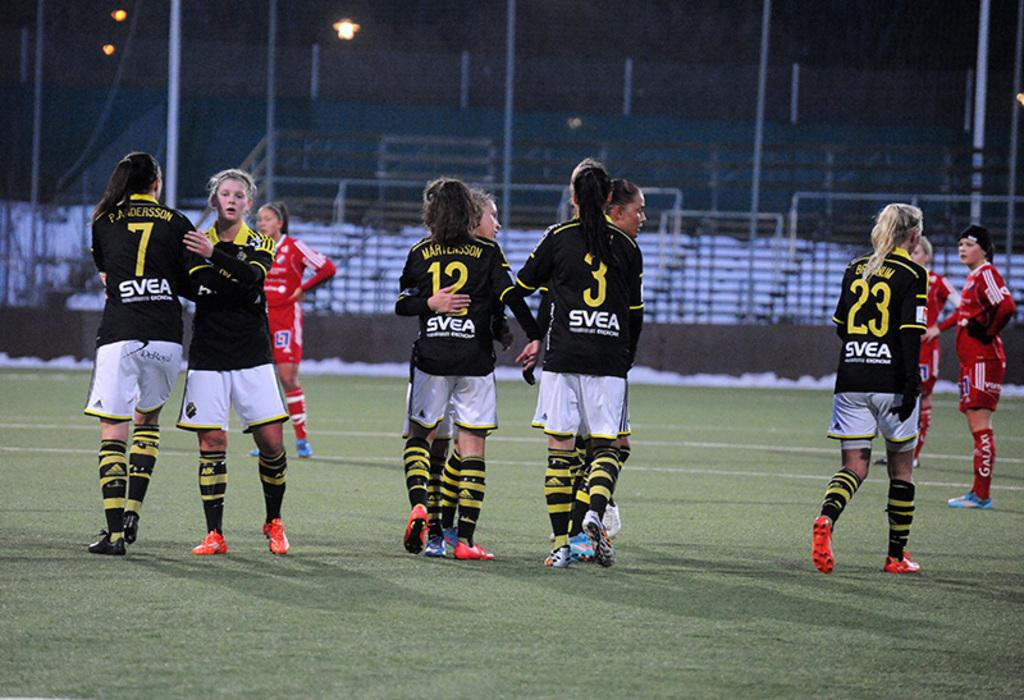<image>
Describe the image concisely. Soccer players on the field with word that says SVEA. 